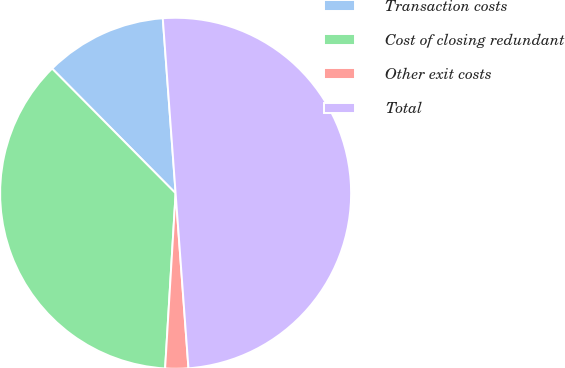Convert chart to OTSL. <chart><loc_0><loc_0><loc_500><loc_500><pie_chart><fcel>Transaction costs<fcel>Cost of closing redundant<fcel>Other exit costs<fcel>Total<nl><fcel>11.26%<fcel>36.62%<fcel>2.12%<fcel>50.0%<nl></chart> 